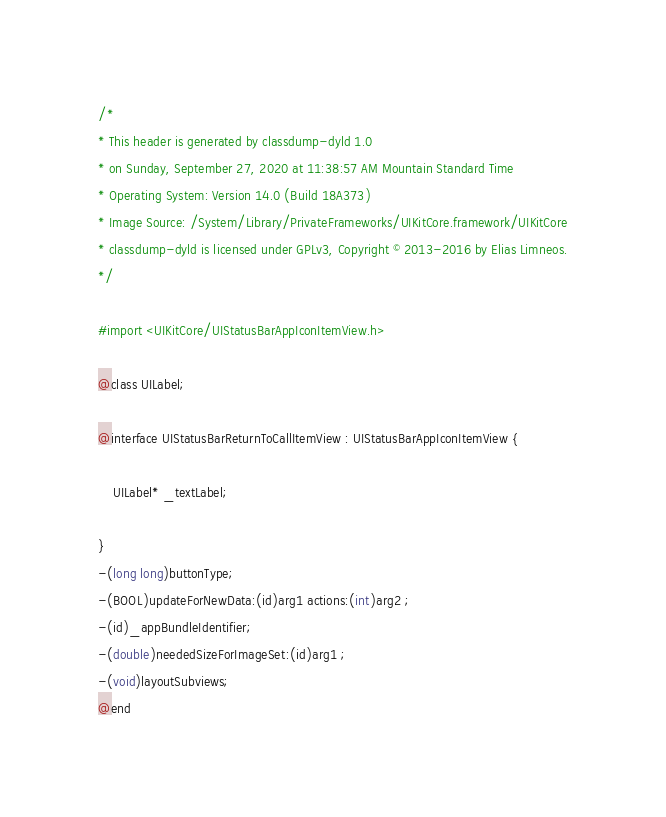Convert code to text. <code><loc_0><loc_0><loc_500><loc_500><_C_>/*
* This header is generated by classdump-dyld 1.0
* on Sunday, September 27, 2020 at 11:38:57 AM Mountain Standard Time
* Operating System: Version 14.0 (Build 18A373)
* Image Source: /System/Library/PrivateFrameworks/UIKitCore.framework/UIKitCore
* classdump-dyld is licensed under GPLv3, Copyright © 2013-2016 by Elias Limneos.
*/

#import <UIKitCore/UIStatusBarAppIconItemView.h>

@class UILabel;

@interface UIStatusBarReturnToCallItemView : UIStatusBarAppIconItemView {

	UILabel* _textLabel;

}
-(long long)buttonType;
-(BOOL)updateForNewData:(id)arg1 actions:(int)arg2 ;
-(id)_appBundleIdentifier;
-(double)neededSizeForImageSet:(id)arg1 ;
-(void)layoutSubviews;
@end

</code> 